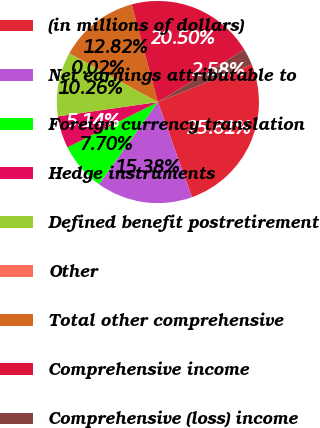<chart> <loc_0><loc_0><loc_500><loc_500><pie_chart><fcel>(in millions of dollars)<fcel>Net earnings attributable to<fcel>Foreign currency translation<fcel>Hedge instruments<fcel>Defined benefit postretirement<fcel>Other<fcel>Total other comprehensive<fcel>Comprehensive income<fcel>Comprehensive (loss) income<nl><fcel>25.62%<fcel>15.38%<fcel>7.7%<fcel>5.14%<fcel>10.26%<fcel>0.02%<fcel>12.82%<fcel>20.5%<fcel>2.58%<nl></chart> 